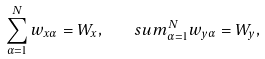Convert formula to latex. <formula><loc_0><loc_0><loc_500><loc_500>\sum _ { \alpha = 1 } ^ { N } w _ { x \alpha } = W _ { x } , \quad s u m _ { \alpha = 1 } ^ { N } w _ { y \alpha } = W _ { y } ,</formula> 